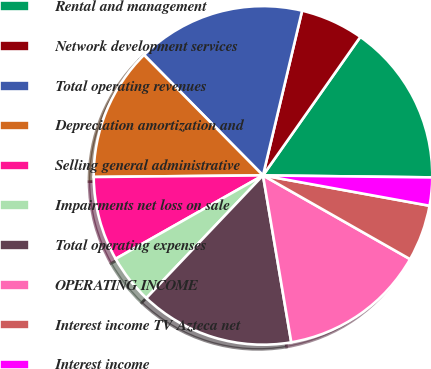Convert chart to OTSL. <chart><loc_0><loc_0><loc_500><loc_500><pie_chart><fcel>Rental and management<fcel>Network development services<fcel>Total operating revenues<fcel>Depreciation amortization and<fcel>Selling general administrative<fcel>Impairments net loss on sale<fcel>Total operating expenses<fcel>OPERATING INCOME<fcel>Interest income TV Azteca net<fcel>Interest income<nl><fcel>15.44%<fcel>6.04%<fcel>16.11%<fcel>12.75%<fcel>8.05%<fcel>4.7%<fcel>14.77%<fcel>14.09%<fcel>5.37%<fcel>2.68%<nl></chart> 